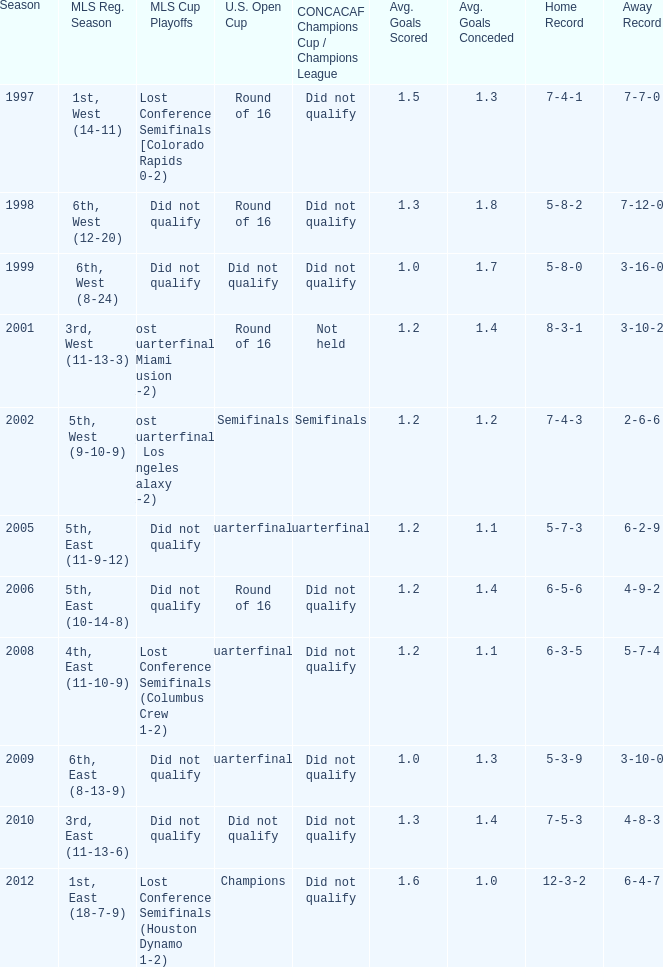Give me the full table as a dictionary. {'header': ['Season', 'MLS Reg. Season', 'MLS Cup Playoffs', 'U.S. Open Cup', 'CONCACAF Champions Cup / Champions League', 'Avg. Goals Scored', 'Avg. Goals Conceded', 'Home Record', 'Away Record'], 'rows': [['1997', '1st, West (14-11)', 'Lost Conference Semifinals [Colorado Rapids 0-2)', 'Round of 16', 'Did not qualify', '1.5', '1.3', '7-4-1', '7-7-0'], ['1998', '6th, West (12-20)', 'Did not qualify', 'Round of 16', 'Did not qualify', '1.3', '1.8', '5-8-2', '7-12-0'], ['1999', '6th, West (8-24)', 'Did not qualify', 'Did not qualify', 'Did not qualify', '1.0', '1.7', '5-8-0', '3-16-0'], ['2001', '3rd, West (11-13-3)', 'Lost Quarterfinals (Miami Fusion 1-2)', 'Round of 16', 'Not held', '1.2', '1.4', '8-3-1', '3-10-2'], ['2002', '5th, West (9-10-9)', 'Lost Quarterfinals ( Los Angeles Galaxy 1-2)', 'Semifinals', 'Semifinals', '1.2', '1.2', '7-4-3', '2-6-6'], ['2005', '5th, East (11-9-12)', 'Did not qualify', 'Quarterfinals', 'Quarterfinals', '1.2', '1.1', '5-7-3', '6-2-9'], ['2006', '5th, East (10-14-8)', 'Did not qualify', 'Round of 16', 'Did not qualify', '1.2', '1.4', '6-5-6', '4-9-2'], ['2008', '4th, East (11-10-9)', 'Lost Conference Semifinals (Columbus Crew 1-2)', 'Quarterfinals', 'Did not qualify', '1.2', '1.1', '6-3-5', '5-7-4'], ['2009', '6th, East (8-13-9)', 'Did not qualify', 'Quarterfinals', 'Did not qualify', '1.0', '1.3', '5-3-9', '3-10-0'], ['2010', '3rd, East (11-13-6)', 'Did not qualify', 'Did not qualify', 'Did not qualify', '1.3', '1.4', '7-5-3', '4-8-3'], ['2012', '1st, East (18-7-9)', 'Lost Conference Semifinals (Houston Dynamo 1-2)', 'Champions', 'Did not qualify', '1.6', '1.0', '12-3-2', '6-4-7']]} How did the team place when they did not qualify for the Concaf Champions Cup but made it to Round of 16 in the U.S. Open Cup? Lost Conference Semifinals [Colorado Rapids 0-2), Did not qualify, Did not qualify. 